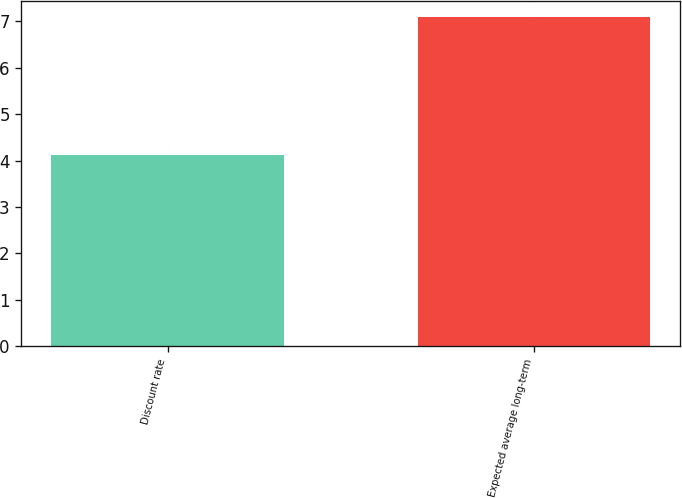Convert chart to OTSL. <chart><loc_0><loc_0><loc_500><loc_500><bar_chart><fcel>Discount rate<fcel>Expected average long-term<nl><fcel>4.11<fcel>7.09<nl></chart> 